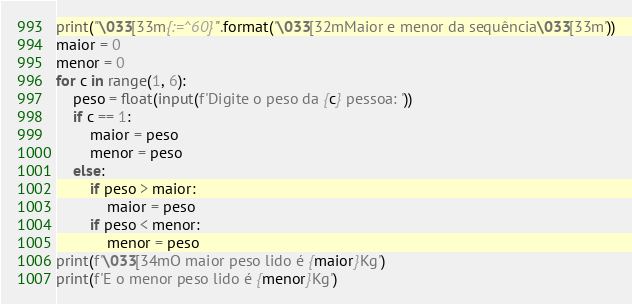<code> <loc_0><loc_0><loc_500><loc_500><_Python_>print("\033[33m{:=^60}".format('\033[32mMaior e menor da sequência\033[33m'))
maior = 0
menor = 0
for c in range(1, 6):
    peso = float(input(f'Digite o peso da {c} pessoa: '))
    if c == 1:
        maior = peso
        menor = peso
    else:
        if peso > maior:
            maior = peso
        if peso < menor:
            menor = peso
print(f'\033[34mO maior peso lido é {maior}Kg')
print(f'E o menor peso lido é {menor}Kg')</code> 